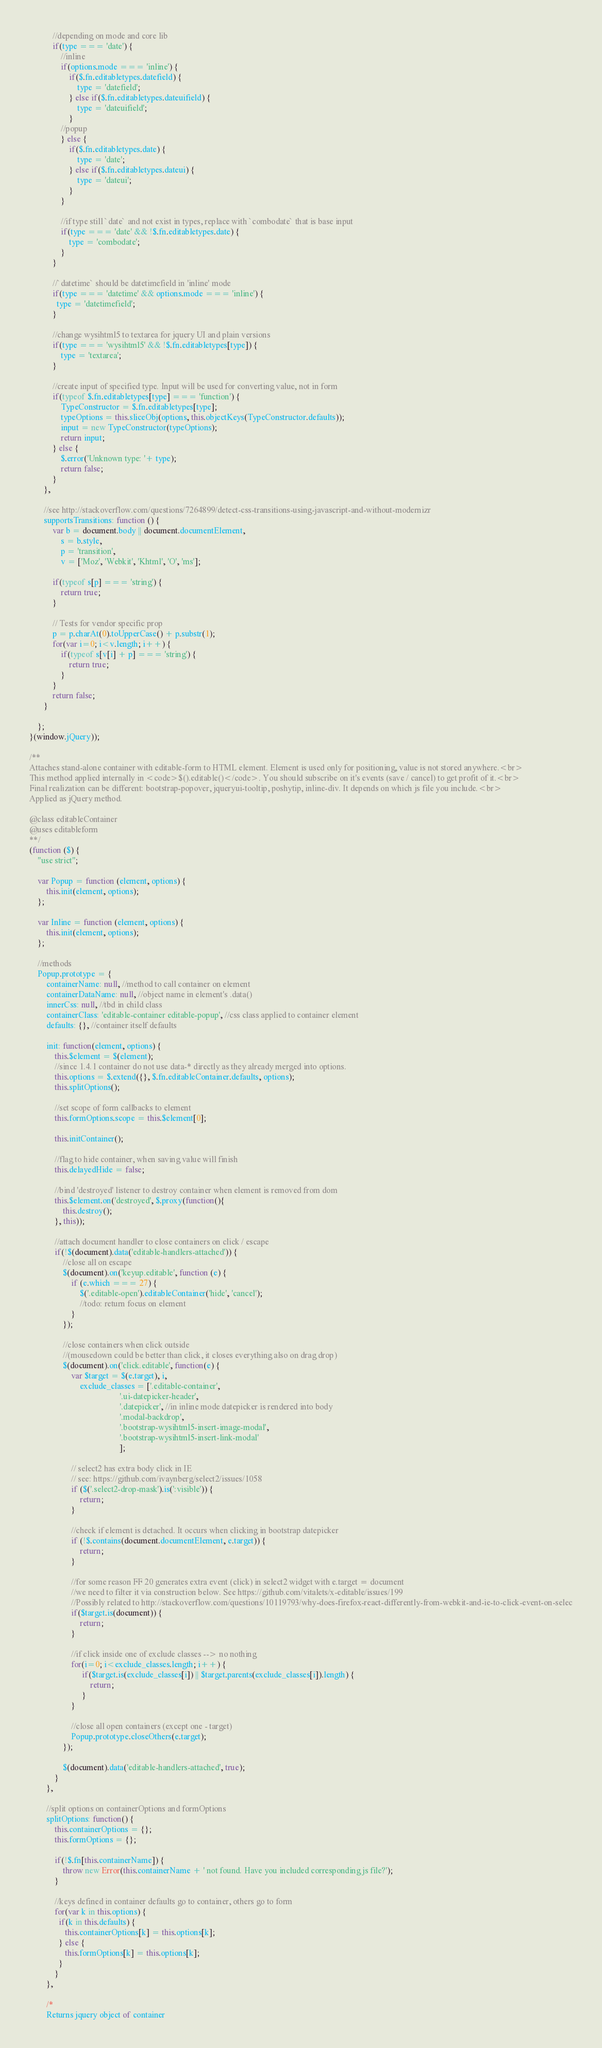<code> <loc_0><loc_0><loc_500><loc_500><_JavaScript_>           //depending on mode and core lib
           if(type === 'date') {
               //inline
               if(options.mode === 'inline') {
                   if($.fn.editabletypes.datefield) {
                       type = 'datefield';
                   } else if($.fn.editabletypes.dateuifield) {
                       type = 'dateuifield';
                   }
               //popup
               } else {
                   if($.fn.editabletypes.date) {
                       type = 'date';
                   } else if($.fn.editabletypes.dateui) {
                       type = 'dateui';
                   }
               }
               
               //if type still `date` and not exist in types, replace with `combodate` that is base input
               if(type === 'date' && !$.fn.editabletypes.date) {
                   type = 'combodate';
               } 
           }
           
           //`datetime` should be datetimefield in 'inline' mode
           if(type === 'datetime' && options.mode === 'inline') {
             type = 'datetimefield';  
           }           

           //change wysihtml5 to textarea for jquery UI and plain versions
           if(type === 'wysihtml5' && !$.fn.editabletypes[type]) {
               type = 'textarea';
           }

           //create input of specified type. Input will be used for converting value, not in form
           if(typeof $.fn.editabletypes[type] === 'function') {
               TypeConstructor = $.fn.editabletypes[type];
               typeOptions = this.sliceObj(options, this.objectKeys(TypeConstructor.defaults));
               input = new TypeConstructor(typeOptions);
               return input;
           } else {
               $.error('Unknown type: '+ type);
               return false; 
           }  
       },
       
       //see http://stackoverflow.com/questions/7264899/detect-css-transitions-using-javascript-and-without-modernizr
       supportsTransitions: function () {
           var b = document.body || document.documentElement,
               s = b.style,
               p = 'transition',
               v = ['Moz', 'Webkit', 'Khtml', 'O', 'ms'];
               
           if(typeof s[p] === 'string') {
               return true; 
           }

           // Tests for vendor specific prop
           p = p.charAt(0).toUpperCase() + p.substr(1);
           for(var i=0; i<v.length; i++) {
               if(typeof s[v[i] + p] === 'string') { 
                   return true; 
               }
           }
           return false;
       }            
       
    };      
}(window.jQuery));

/**
Attaches stand-alone container with editable-form to HTML element. Element is used only for positioning, value is not stored anywhere.<br>
This method applied internally in <code>$().editable()</code>. You should subscribe on it's events (save / cancel) to get profit of it.<br>
Final realization can be different: bootstrap-popover, jqueryui-tooltip, poshytip, inline-div. It depends on which js file you include.<br>
Applied as jQuery method.

@class editableContainer
@uses editableform
**/
(function ($) {
    "use strict";

    var Popup = function (element, options) {
        this.init(element, options);
    };
    
    var Inline = function (element, options) {
        this.init(element, options);
    };    

    //methods
    Popup.prototype = {
        containerName: null, //method to call container on element
        containerDataName: null, //object name in element's .data()
        innerCss: null, //tbd in child class
        containerClass: 'editable-container editable-popup', //css class applied to container element
        defaults: {}, //container itself defaults
        
        init: function(element, options) {
            this.$element = $(element);
            //since 1.4.1 container do not use data-* directly as they already merged into options.
            this.options = $.extend({}, $.fn.editableContainer.defaults, options);         
            this.splitOptions();
            
            //set scope of form callbacks to element
            this.formOptions.scope = this.$element[0]; 
            
            this.initContainer();
            
            //flag to hide container, when saving value will finish
            this.delayedHide = false;

            //bind 'destroyed' listener to destroy container when element is removed from dom
            this.$element.on('destroyed', $.proxy(function(){
                this.destroy();
            }, this)); 
            
            //attach document handler to close containers on click / escape
            if(!$(document).data('editable-handlers-attached')) {
                //close all on escape
                $(document).on('keyup.editable', function (e) {
                    if (e.which === 27) {
                        $('.editable-open').editableContainer('hide', 'cancel');
                        //todo: return focus on element 
                    }
                });

                //close containers when click outside 
                //(mousedown could be better than click, it closes everything also on drag drop)
                $(document).on('click.editable', function(e) {
                    var $target = $(e.target), i,
                        exclude_classes = ['.editable-container', 
                                           '.ui-datepicker-header', 
                                           '.datepicker', //in inline mode datepicker is rendered into body
                                           '.modal-backdrop', 
                                           '.bootstrap-wysihtml5-insert-image-modal', 
                                           '.bootstrap-wysihtml5-insert-link-modal'
                                           ];

                    // select2 has extra body click in IE
                    // see: https://github.com/ivaynberg/select2/issues/1058 
                    if ($('.select2-drop-mask').is(':visible')) {
                        return;
                    }

                    //check if element is detached. It occurs when clicking in bootstrap datepicker
                    if (!$.contains(document.documentElement, e.target)) {
                        return;
                    }

                    //for some reason FF 20 generates extra event (click) in select2 widget with e.target = document
                    //we need to filter it via construction below. See https://github.com/vitalets/x-editable/issues/199
                    //Possibly related to http://stackoverflow.com/questions/10119793/why-does-firefox-react-differently-from-webkit-and-ie-to-click-event-on-selec
                    if($target.is(document)) {
                        return;
                    }
                    
                    //if click inside one of exclude classes --> no nothing
                    for(i=0; i<exclude_classes.length; i++) {
                         if($target.is(exclude_classes[i]) || $target.parents(exclude_classes[i]).length) {
                             return;
                         }
                    }
                      
                    //close all open containers (except one - target)
                    Popup.prototype.closeOthers(e.target);
                });
                
                $(document).data('editable-handlers-attached', true);
            }                        
        },

        //split options on containerOptions and formOptions
        splitOptions: function() {
            this.containerOptions = {};
            this.formOptions = {};
            
            if(!$.fn[this.containerName]) {
                throw new Error(this.containerName + ' not found. Have you included corresponding js file?');   
            }
            
            //keys defined in container defaults go to container, others go to form
            for(var k in this.options) {
              if(k in this.defaults) {
                 this.containerOptions[k] = this.options[k];
              } else {
                 this.formOptions[k] = this.options[k];
              } 
            }
        },
        
        /*
        Returns jquery object of container</code> 